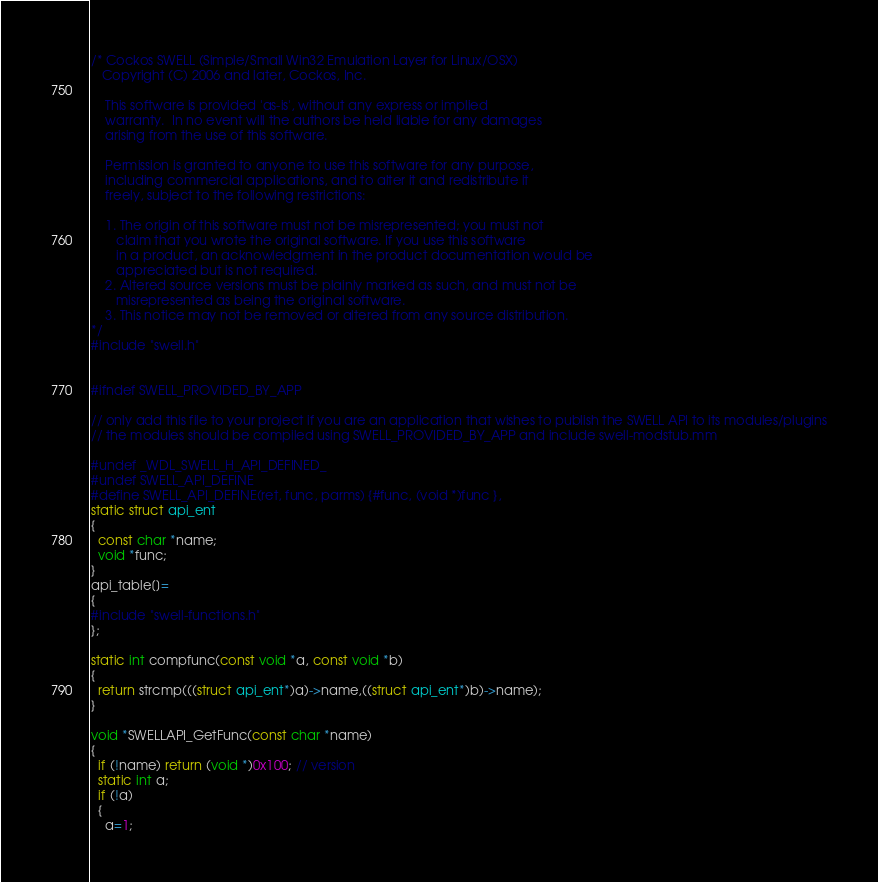Convert code to text. <code><loc_0><loc_0><loc_500><loc_500><_ObjectiveC_>/* Cockos SWELL (Simple/Small Win32 Emulation Layer for Linux/OSX)
   Copyright (C) 2006 and later, Cockos, Inc.

    This software is provided 'as-is', without any express or implied
    warranty.  In no event will the authors be held liable for any damages
    arising from the use of this software.

    Permission is granted to anyone to use this software for any purpose,
    including commercial applications, and to alter it and redistribute it
    freely, subject to the following restrictions:

    1. The origin of this software must not be misrepresented; you must not
       claim that you wrote the original software. If you use this software
       in a product, an acknowledgment in the product documentation would be
       appreciated but is not required.
    2. Altered source versions must be plainly marked as such, and must not be
       misrepresented as being the original software.
    3. This notice may not be removed or altered from any source distribution.
*/  
#include "swell.h"


#ifndef SWELL_PROVIDED_BY_APP

// only add this file to your project if you are an application that wishes to publish the SWELL API to its modules/plugins
// the modules should be compiled using SWELL_PROVIDED_BY_APP and include swell-modstub.mm

#undef _WDL_SWELL_H_API_DEFINED_
#undef SWELL_API_DEFINE
#define SWELL_API_DEFINE(ret, func, parms) {#func, (void *)func },
static struct api_ent
{
  const char *name;
  void *func;
}
api_table[]=
{
#include "swell-functions.h"
};

static int compfunc(const void *a, const void *b)
{
  return strcmp(((struct api_ent*)a)->name,((struct api_ent*)b)->name);
}

void *SWELLAPI_GetFunc(const char *name)
{
  if (!name) return (void *)0x100; // version
  static int a; 
  if (!a)
  { 
	a=1;</code> 